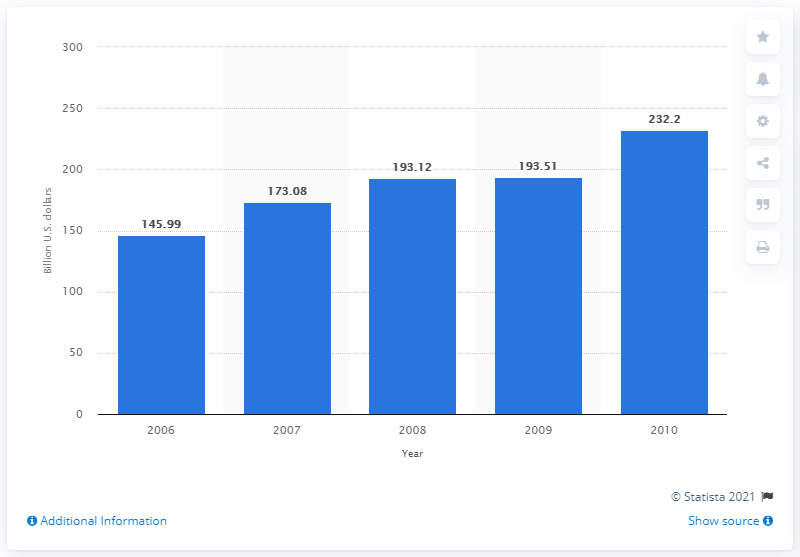Outline some significant characteristics in this image. In 2008, the total retail net sales in Indonesia amounted to 193.51 dollars. 